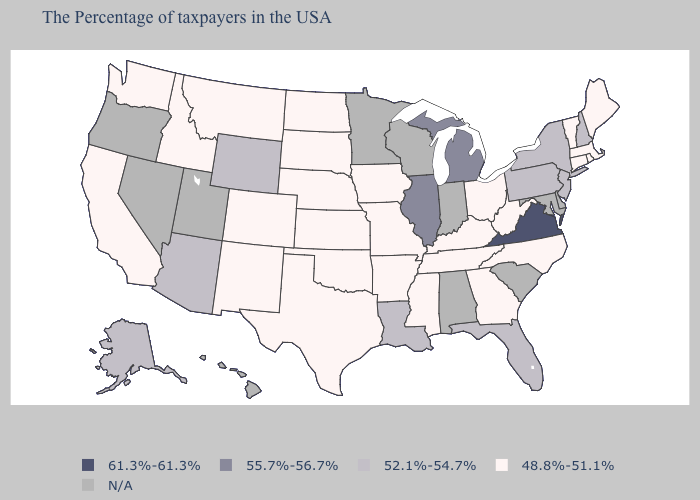Does Mississippi have the lowest value in the USA?
Short answer required. Yes. What is the lowest value in the USA?
Concise answer only. 48.8%-51.1%. Which states hav the highest value in the MidWest?
Be succinct. Michigan, Illinois. Does Illinois have the lowest value in the MidWest?
Write a very short answer. No. Does the first symbol in the legend represent the smallest category?
Give a very brief answer. No. Among the states that border Arkansas , does Louisiana have the lowest value?
Keep it brief. No. Does the first symbol in the legend represent the smallest category?
Short answer required. No. How many symbols are there in the legend?
Write a very short answer. 5. What is the value of Connecticut?
Keep it brief. 48.8%-51.1%. Name the states that have a value in the range 55.7%-56.7%?
Short answer required. Michigan, Illinois. What is the lowest value in the USA?
Write a very short answer. 48.8%-51.1%. Among the states that border Arkansas , does Missouri have the highest value?
Be succinct. No. Does the first symbol in the legend represent the smallest category?
Keep it brief. No. What is the lowest value in states that border Idaho?
Answer briefly. 48.8%-51.1%. What is the lowest value in states that border Kentucky?
Answer briefly. 48.8%-51.1%. 